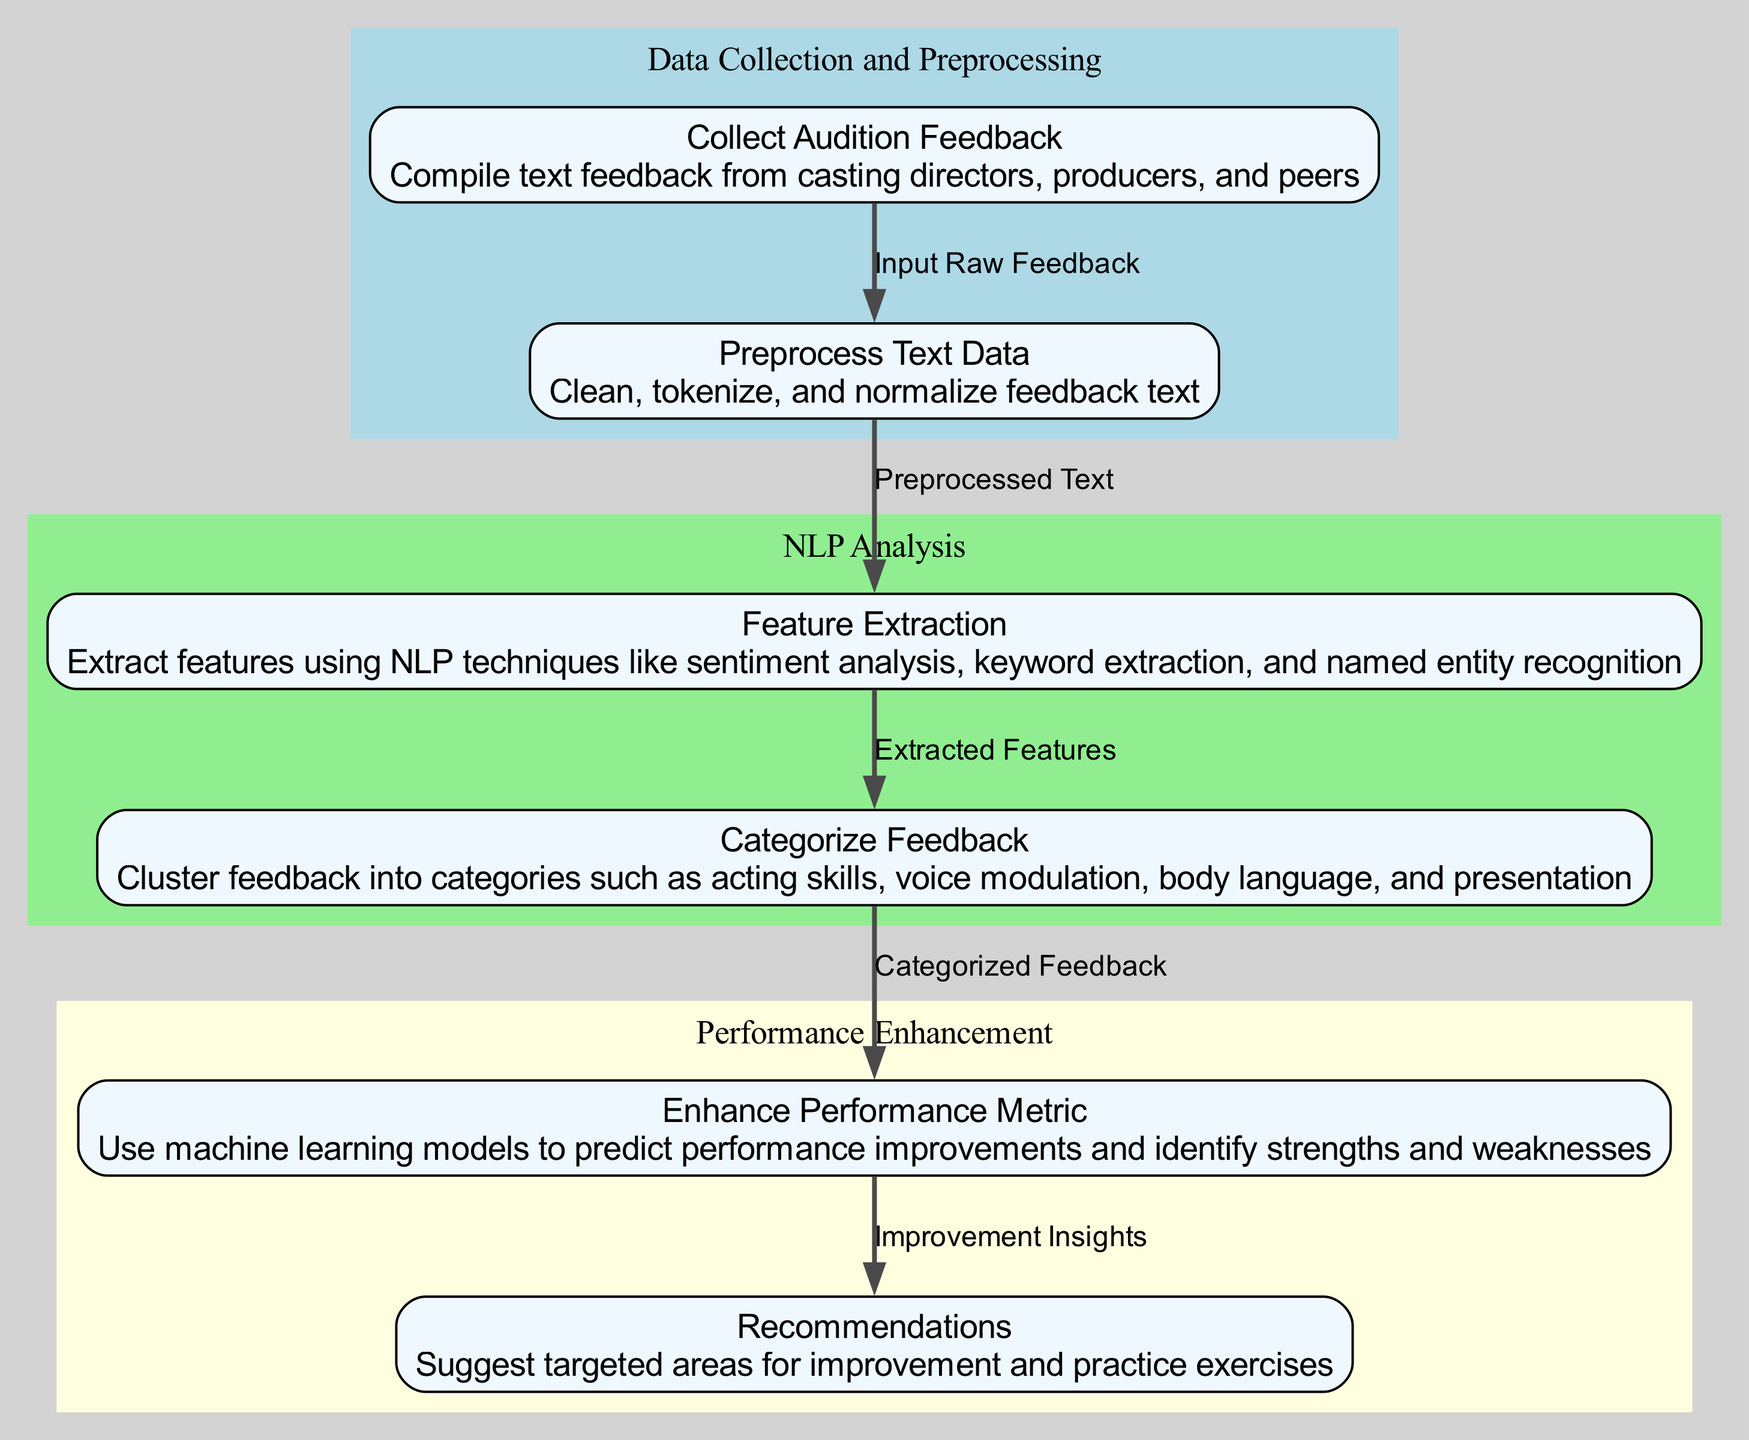What is the first step in the diagram? The diagram begins with the node labeled "Collect Audition Feedback", which is the first step in the process of analyzing audition feedback.
Answer: Collect Audition Feedback How many steps are there in the diagram? The diagram contains a total of six steps, as indicated by the six nodes present.
Answer: Six What type of techniques are used in step three? In step three, the techniques used are NLP techniques, specifically referenced as sentiment analysis, keyword extraction, and named entity recognition.
Answer: NLP techniques What is the relationship between the last two steps? The relationship between the last two steps is that the "Enhance Performance Metric" provides "Recommendations" based on the improvement insights generated in the previous step.
Answer: Improvement insights Which step focuses on preprocessing the text data? The step that focuses on preprocessing the text data is labeled "Preprocess Text Data", which involves cleaning, tokenizing, and normalizing the feedback text.
Answer: Preprocess Text Data What is the primary output after "Categorize Feedback"? After "Categorize Feedback", the primary output is "Enhance Performance Metric", which relies on the categorized feedback to predict improvements and identify acting strengths and weaknesses.
Answer: Enhance Performance Metric What category follows "Feature Extraction" in the diagram? The category that follows "Feature Extraction" in the diagram is "Categorize Feedback", where the extracted features are clustered into categories.
Answer: Categorize Feedback What are the last two nodes collectively focused on? The last two nodes, "Enhance Performance Metric" and "Recommendations", are collectively focused on improving performance by identifying strengths and weaknesses and suggesting areas for improvement.
Answer: Performance Improvement What is the main purpose of the diagram? The main purpose of the diagram is to visually represent the process of analyzing audition feedback using NLP techniques to enhance an actor's performance.
Answer: Analyze audition feedback 